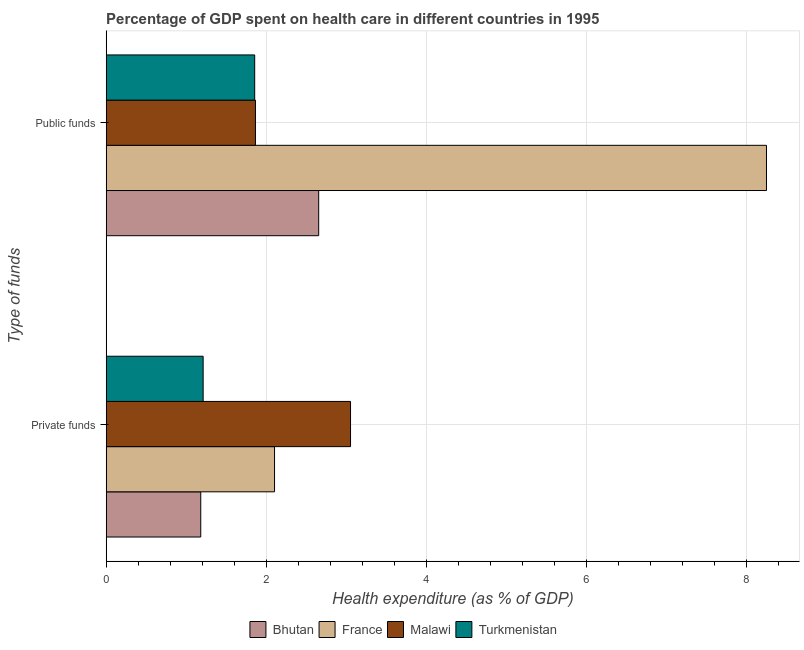How many groups of bars are there?
Make the answer very short. 2. Are the number of bars per tick equal to the number of legend labels?
Provide a short and direct response. Yes. Are the number of bars on each tick of the Y-axis equal?
Provide a short and direct response. Yes. How many bars are there on the 1st tick from the bottom?
Offer a very short reply. 4. What is the label of the 2nd group of bars from the top?
Ensure brevity in your answer.  Private funds. What is the amount of public funds spent in healthcare in Turkmenistan?
Keep it short and to the point. 1.86. Across all countries, what is the maximum amount of public funds spent in healthcare?
Your answer should be very brief. 8.25. Across all countries, what is the minimum amount of private funds spent in healthcare?
Your answer should be compact. 1.18. In which country was the amount of public funds spent in healthcare maximum?
Give a very brief answer. France. In which country was the amount of private funds spent in healthcare minimum?
Keep it short and to the point. Bhutan. What is the total amount of private funds spent in healthcare in the graph?
Offer a terse response. 7.55. What is the difference between the amount of public funds spent in healthcare in Malawi and that in Turkmenistan?
Keep it short and to the point. 0.01. What is the difference between the amount of private funds spent in healthcare in Turkmenistan and the amount of public funds spent in healthcare in Malawi?
Ensure brevity in your answer.  -0.65. What is the average amount of public funds spent in healthcare per country?
Provide a succinct answer. 3.66. What is the difference between the amount of private funds spent in healthcare and amount of public funds spent in healthcare in Turkmenistan?
Offer a very short reply. -0.64. In how many countries, is the amount of private funds spent in healthcare greater than 1.2000000000000002 %?
Your response must be concise. 3. What is the ratio of the amount of public funds spent in healthcare in Turkmenistan to that in France?
Make the answer very short. 0.22. Is the amount of public funds spent in healthcare in France less than that in Malawi?
Your answer should be compact. No. In how many countries, is the amount of private funds spent in healthcare greater than the average amount of private funds spent in healthcare taken over all countries?
Give a very brief answer. 2. What does the 1st bar from the bottom in Public funds represents?
Offer a very short reply. Bhutan. Are all the bars in the graph horizontal?
Provide a succinct answer. Yes. How many countries are there in the graph?
Offer a very short reply. 4. What is the difference between two consecutive major ticks on the X-axis?
Your response must be concise. 2. Are the values on the major ticks of X-axis written in scientific E-notation?
Offer a very short reply. No. How many legend labels are there?
Give a very brief answer. 4. How are the legend labels stacked?
Your answer should be very brief. Horizontal. What is the title of the graph?
Give a very brief answer. Percentage of GDP spent on health care in different countries in 1995. What is the label or title of the X-axis?
Your answer should be very brief. Health expenditure (as % of GDP). What is the label or title of the Y-axis?
Your answer should be very brief. Type of funds. What is the Health expenditure (as % of GDP) of Bhutan in Private funds?
Make the answer very short. 1.18. What is the Health expenditure (as % of GDP) in France in Private funds?
Provide a succinct answer. 2.1. What is the Health expenditure (as % of GDP) of Malawi in Private funds?
Ensure brevity in your answer.  3.05. What is the Health expenditure (as % of GDP) in Turkmenistan in Private funds?
Give a very brief answer. 1.21. What is the Health expenditure (as % of GDP) of Bhutan in Public funds?
Provide a succinct answer. 2.66. What is the Health expenditure (as % of GDP) of France in Public funds?
Offer a terse response. 8.25. What is the Health expenditure (as % of GDP) in Malawi in Public funds?
Ensure brevity in your answer.  1.87. What is the Health expenditure (as % of GDP) of Turkmenistan in Public funds?
Provide a short and direct response. 1.86. Across all Type of funds, what is the maximum Health expenditure (as % of GDP) of Bhutan?
Your response must be concise. 2.66. Across all Type of funds, what is the maximum Health expenditure (as % of GDP) in France?
Provide a succinct answer. 8.25. Across all Type of funds, what is the maximum Health expenditure (as % of GDP) in Malawi?
Your response must be concise. 3.05. Across all Type of funds, what is the maximum Health expenditure (as % of GDP) in Turkmenistan?
Give a very brief answer. 1.86. Across all Type of funds, what is the minimum Health expenditure (as % of GDP) in Bhutan?
Make the answer very short. 1.18. Across all Type of funds, what is the minimum Health expenditure (as % of GDP) of France?
Offer a very short reply. 2.1. Across all Type of funds, what is the minimum Health expenditure (as % of GDP) in Malawi?
Make the answer very short. 1.87. Across all Type of funds, what is the minimum Health expenditure (as % of GDP) of Turkmenistan?
Your answer should be very brief. 1.21. What is the total Health expenditure (as % of GDP) of Bhutan in the graph?
Your answer should be compact. 3.84. What is the total Health expenditure (as % of GDP) in France in the graph?
Ensure brevity in your answer.  10.36. What is the total Health expenditure (as % of GDP) in Malawi in the graph?
Keep it short and to the point. 4.92. What is the total Health expenditure (as % of GDP) in Turkmenistan in the graph?
Your answer should be very brief. 3.07. What is the difference between the Health expenditure (as % of GDP) of Bhutan in Private funds and that in Public funds?
Provide a short and direct response. -1.47. What is the difference between the Health expenditure (as % of GDP) in France in Private funds and that in Public funds?
Offer a terse response. -6.15. What is the difference between the Health expenditure (as % of GDP) of Malawi in Private funds and that in Public funds?
Offer a terse response. 1.19. What is the difference between the Health expenditure (as % of GDP) of Turkmenistan in Private funds and that in Public funds?
Offer a very short reply. -0.64. What is the difference between the Health expenditure (as % of GDP) of Bhutan in Private funds and the Health expenditure (as % of GDP) of France in Public funds?
Provide a succinct answer. -7.07. What is the difference between the Health expenditure (as % of GDP) of Bhutan in Private funds and the Health expenditure (as % of GDP) of Malawi in Public funds?
Give a very brief answer. -0.68. What is the difference between the Health expenditure (as % of GDP) in Bhutan in Private funds and the Health expenditure (as % of GDP) in Turkmenistan in Public funds?
Your answer should be compact. -0.67. What is the difference between the Health expenditure (as % of GDP) in France in Private funds and the Health expenditure (as % of GDP) in Malawi in Public funds?
Offer a terse response. 0.24. What is the difference between the Health expenditure (as % of GDP) of France in Private funds and the Health expenditure (as % of GDP) of Turkmenistan in Public funds?
Offer a terse response. 0.25. What is the difference between the Health expenditure (as % of GDP) in Malawi in Private funds and the Health expenditure (as % of GDP) in Turkmenistan in Public funds?
Your answer should be very brief. 1.2. What is the average Health expenditure (as % of GDP) of Bhutan per Type of funds?
Give a very brief answer. 1.92. What is the average Health expenditure (as % of GDP) in France per Type of funds?
Give a very brief answer. 5.18. What is the average Health expenditure (as % of GDP) in Malawi per Type of funds?
Your answer should be very brief. 2.46. What is the average Health expenditure (as % of GDP) in Turkmenistan per Type of funds?
Your answer should be very brief. 1.53. What is the difference between the Health expenditure (as % of GDP) in Bhutan and Health expenditure (as % of GDP) in France in Private funds?
Provide a succinct answer. -0.92. What is the difference between the Health expenditure (as % of GDP) in Bhutan and Health expenditure (as % of GDP) in Malawi in Private funds?
Provide a succinct answer. -1.87. What is the difference between the Health expenditure (as % of GDP) of Bhutan and Health expenditure (as % of GDP) of Turkmenistan in Private funds?
Keep it short and to the point. -0.03. What is the difference between the Health expenditure (as % of GDP) of France and Health expenditure (as % of GDP) of Malawi in Private funds?
Your answer should be very brief. -0.95. What is the difference between the Health expenditure (as % of GDP) in France and Health expenditure (as % of GDP) in Turkmenistan in Private funds?
Provide a short and direct response. 0.89. What is the difference between the Health expenditure (as % of GDP) in Malawi and Health expenditure (as % of GDP) in Turkmenistan in Private funds?
Ensure brevity in your answer.  1.84. What is the difference between the Health expenditure (as % of GDP) of Bhutan and Health expenditure (as % of GDP) of France in Public funds?
Your answer should be very brief. -5.6. What is the difference between the Health expenditure (as % of GDP) in Bhutan and Health expenditure (as % of GDP) in Malawi in Public funds?
Your response must be concise. 0.79. What is the difference between the Health expenditure (as % of GDP) of Bhutan and Health expenditure (as % of GDP) of Turkmenistan in Public funds?
Ensure brevity in your answer.  0.8. What is the difference between the Health expenditure (as % of GDP) in France and Health expenditure (as % of GDP) in Malawi in Public funds?
Your response must be concise. 6.39. What is the difference between the Health expenditure (as % of GDP) in France and Health expenditure (as % of GDP) in Turkmenistan in Public funds?
Make the answer very short. 6.4. What is the difference between the Health expenditure (as % of GDP) in Malawi and Health expenditure (as % of GDP) in Turkmenistan in Public funds?
Your response must be concise. 0.01. What is the ratio of the Health expenditure (as % of GDP) of Bhutan in Private funds to that in Public funds?
Keep it short and to the point. 0.44. What is the ratio of the Health expenditure (as % of GDP) in France in Private funds to that in Public funds?
Offer a very short reply. 0.25. What is the ratio of the Health expenditure (as % of GDP) of Malawi in Private funds to that in Public funds?
Ensure brevity in your answer.  1.64. What is the ratio of the Health expenditure (as % of GDP) in Turkmenistan in Private funds to that in Public funds?
Ensure brevity in your answer.  0.65. What is the difference between the highest and the second highest Health expenditure (as % of GDP) of Bhutan?
Your answer should be very brief. 1.47. What is the difference between the highest and the second highest Health expenditure (as % of GDP) in France?
Your answer should be compact. 6.15. What is the difference between the highest and the second highest Health expenditure (as % of GDP) of Malawi?
Ensure brevity in your answer.  1.19. What is the difference between the highest and the second highest Health expenditure (as % of GDP) of Turkmenistan?
Give a very brief answer. 0.64. What is the difference between the highest and the lowest Health expenditure (as % of GDP) in Bhutan?
Offer a terse response. 1.47. What is the difference between the highest and the lowest Health expenditure (as % of GDP) in France?
Your response must be concise. 6.15. What is the difference between the highest and the lowest Health expenditure (as % of GDP) of Malawi?
Your response must be concise. 1.19. What is the difference between the highest and the lowest Health expenditure (as % of GDP) of Turkmenistan?
Make the answer very short. 0.64. 